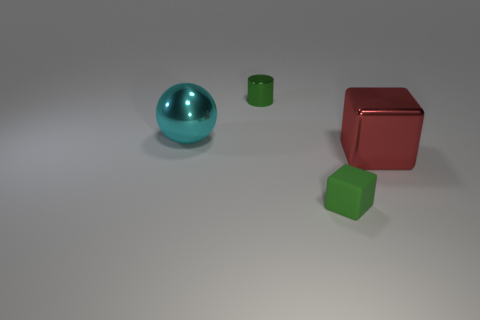What number of cubes are either matte things or large red things?
Offer a terse response. 2. What material is the object that is the same color as the metallic cylinder?
Keep it short and to the point. Rubber. There is a sphere; is it the same color as the tiny object behind the tiny green cube?
Provide a short and direct response. No. What is the color of the rubber block?
Your answer should be compact. Green. How many things are cyan things or small rubber blocks?
Provide a short and direct response. 2. There is a red thing that is the same size as the metallic sphere; what is its material?
Your answer should be compact. Metal. There is a shiny object on the left side of the small cylinder; what size is it?
Provide a short and direct response. Large. What is the large red object made of?
Provide a succinct answer. Metal. How many things are either small green objects that are in front of the large red object or tiny green things behind the matte cube?
Keep it short and to the point. 2. What number of other things are there of the same color as the small rubber cube?
Provide a succinct answer. 1. 